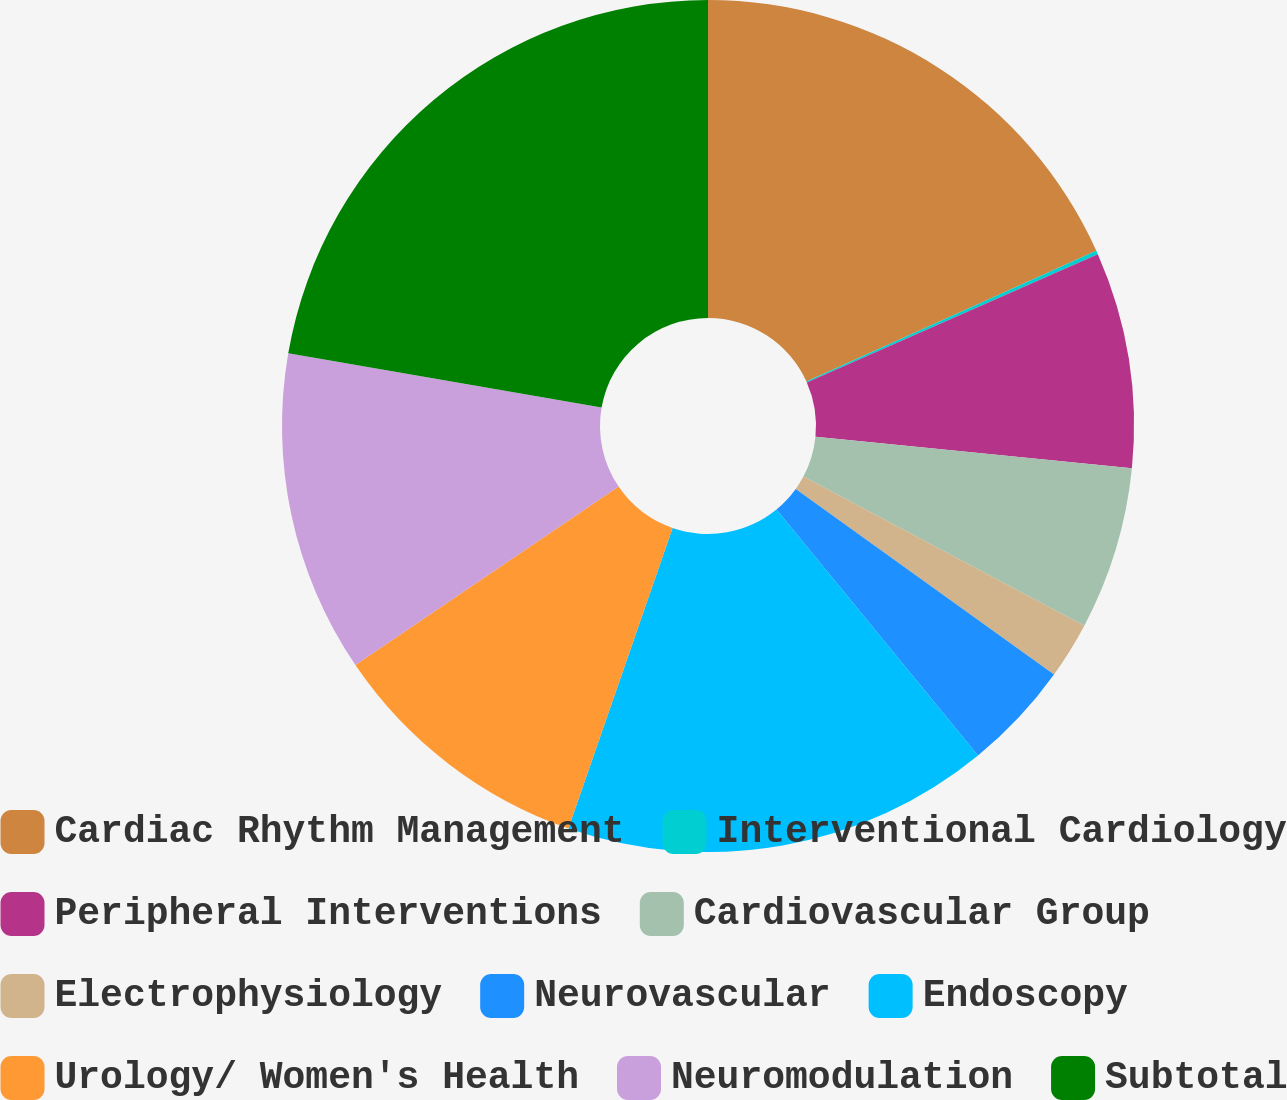<chart> <loc_0><loc_0><loc_500><loc_500><pie_chart><fcel>Cardiac Rhythm Management<fcel>Interventional Cardiology<fcel>Peripheral Interventions<fcel>Cardiovascular Group<fcel>Electrophysiology<fcel>Neurovascular<fcel>Endoscopy<fcel>Urology/ Women's Health<fcel>Neuromodulation<fcel>Subtotal<nl><fcel>18.25%<fcel>0.14%<fcel>8.19%<fcel>6.18%<fcel>2.15%<fcel>4.16%<fcel>16.24%<fcel>10.2%<fcel>12.21%<fcel>22.27%<nl></chart> 